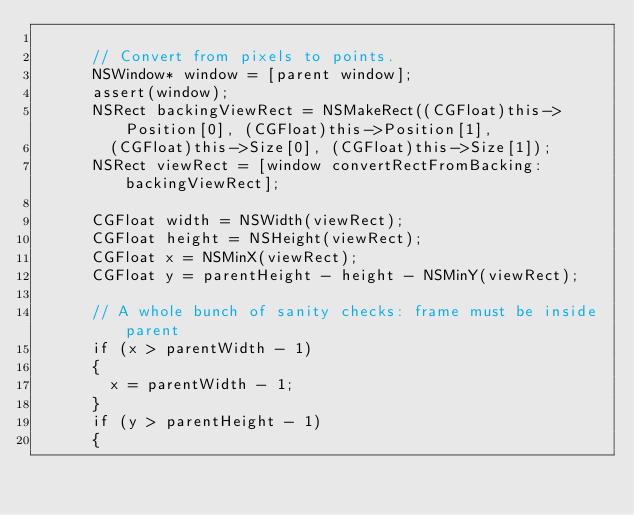Convert code to text. <code><loc_0><loc_0><loc_500><loc_500><_ObjectiveC_>
      // Convert from pixels to points.
      NSWindow* window = [parent window];
      assert(window);
      NSRect backingViewRect = NSMakeRect((CGFloat)this->Position[0], (CGFloat)this->Position[1],
        (CGFloat)this->Size[0], (CGFloat)this->Size[1]);
      NSRect viewRect = [window convertRectFromBacking:backingViewRect];

      CGFloat width = NSWidth(viewRect);
      CGFloat height = NSHeight(viewRect);
      CGFloat x = NSMinX(viewRect);
      CGFloat y = parentHeight - height - NSMinY(viewRect);

      // A whole bunch of sanity checks: frame must be inside parent
      if (x > parentWidth - 1)
      {
        x = parentWidth - 1;
      }
      if (y > parentHeight - 1)
      {</code> 